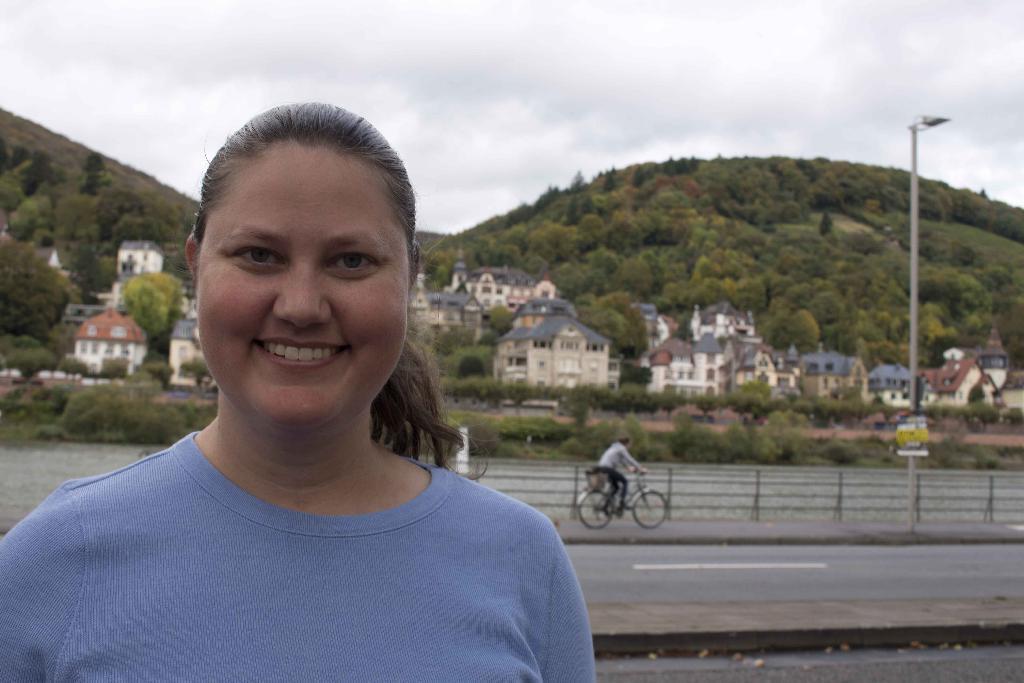How would you summarize this image in a sentence or two? In this image there is women, she is wearing a blue color T-shirt, in the background there is road and footpath and a river footpath and river are separated with fencing ,in the background there are houses, trees and mountains and a sky. 